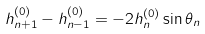<formula> <loc_0><loc_0><loc_500><loc_500>h ^ { ( 0 ) } _ { n + 1 } - h ^ { ( 0 ) } _ { n - 1 } = - 2 h ^ { ( 0 ) } _ { n } \sin \theta _ { n }</formula> 